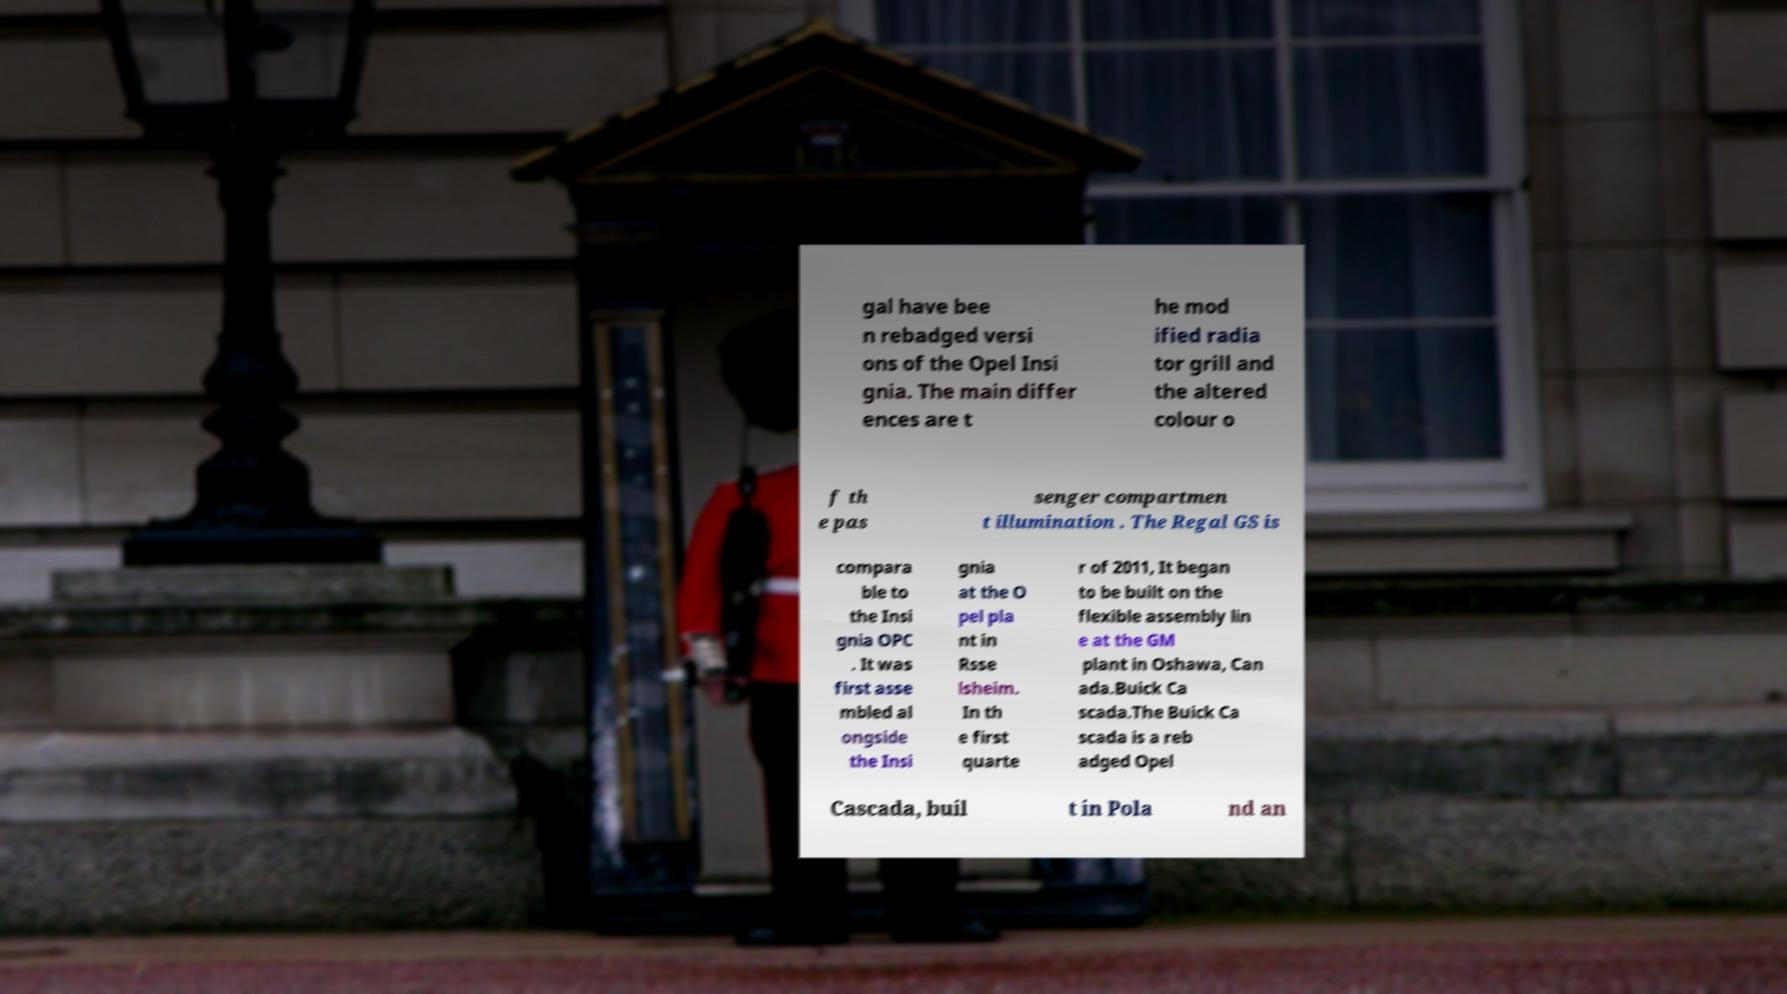What messages or text are displayed in this image? I need them in a readable, typed format. gal have bee n rebadged versi ons of the Opel Insi gnia. The main differ ences are t he mod ified radia tor grill and the altered colour o f th e pas senger compartmen t illumination . The Regal GS is compara ble to the Insi gnia OPC . It was first asse mbled al ongside the Insi gnia at the O pel pla nt in Rsse lsheim. In th e first quarte r of 2011, It began to be built on the flexible assembly lin e at the GM plant in Oshawa, Can ada.Buick Ca scada.The Buick Ca scada is a reb adged Opel Cascada, buil t in Pola nd an 